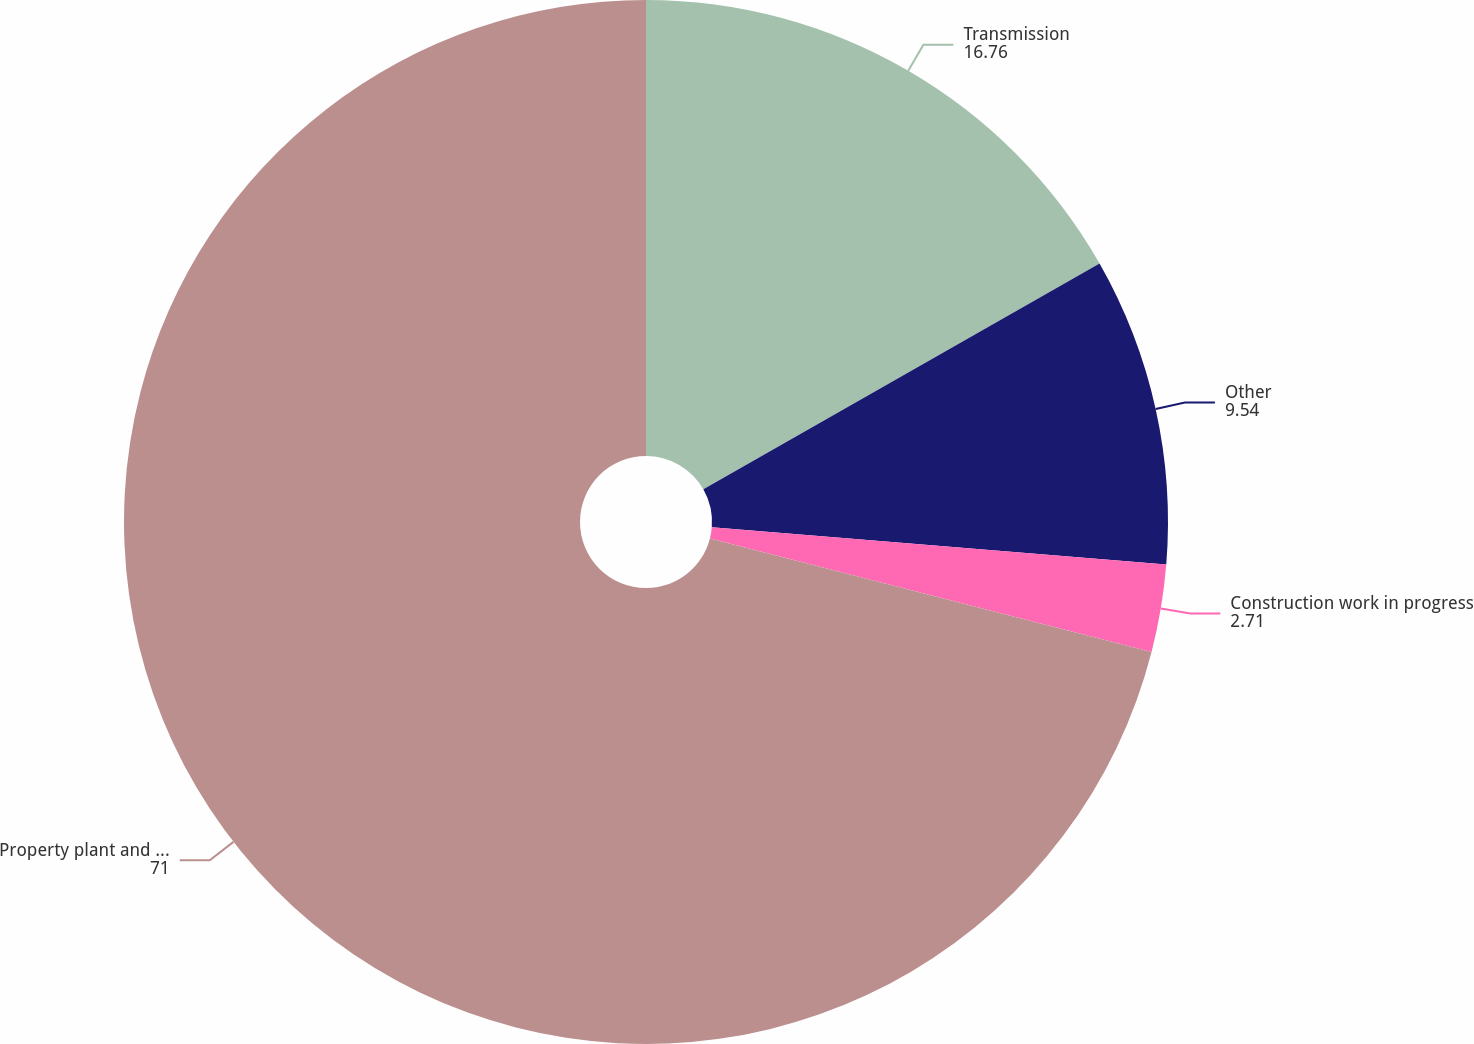Convert chart. <chart><loc_0><loc_0><loc_500><loc_500><pie_chart><fcel>Transmission<fcel>Other<fcel>Construction work in progress<fcel>Property plant and equipment -<nl><fcel>16.76%<fcel>9.54%<fcel>2.71%<fcel>71.0%<nl></chart> 